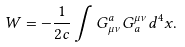<formula> <loc_0><loc_0><loc_500><loc_500>W = - \frac { 1 } { 2 c } \int G ^ { a } _ { \mu \nu } G _ { a } ^ { \mu \nu } d ^ { 4 } x .</formula> 